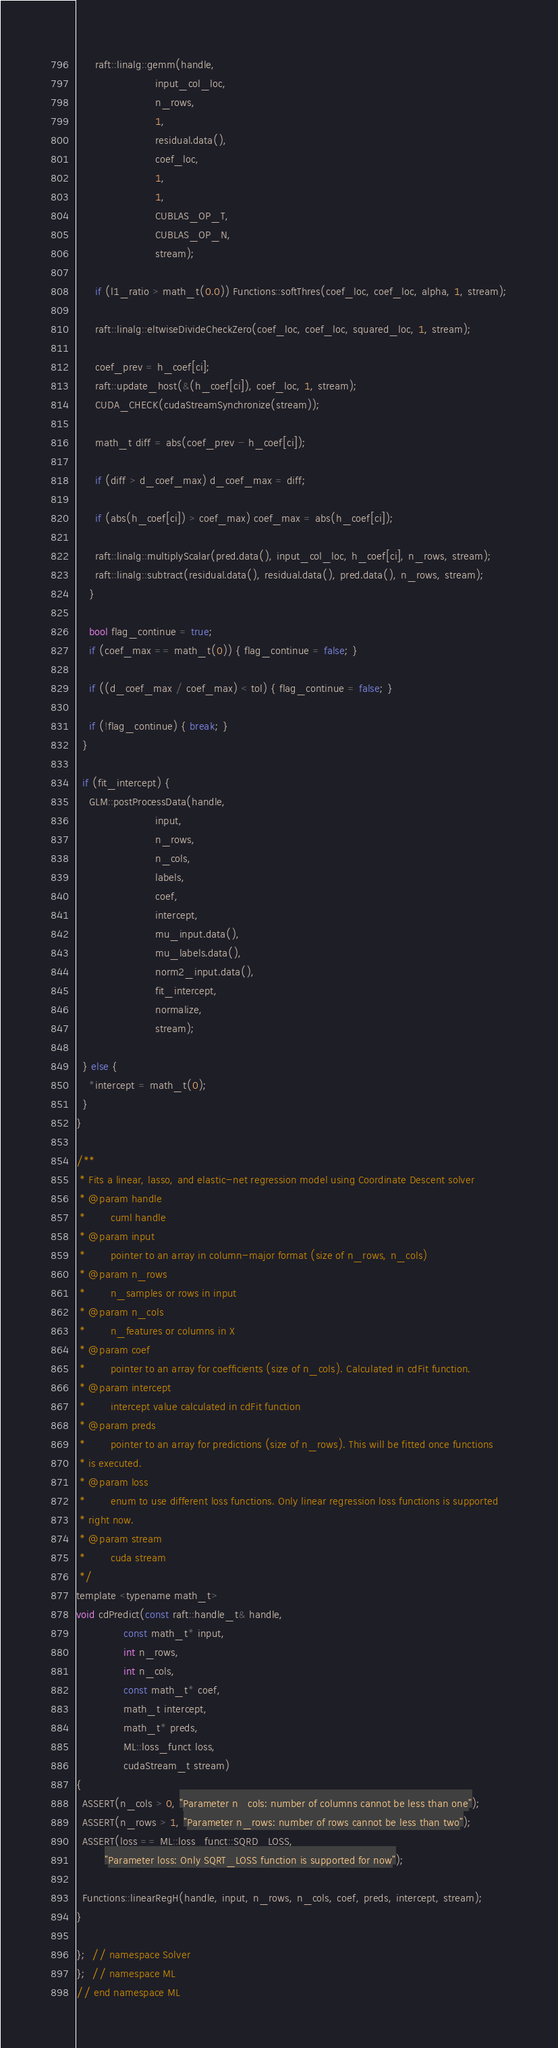Convert code to text. <code><loc_0><loc_0><loc_500><loc_500><_Cuda_>      raft::linalg::gemm(handle,
                         input_col_loc,
                         n_rows,
                         1,
                         residual.data(),
                         coef_loc,
                         1,
                         1,
                         CUBLAS_OP_T,
                         CUBLAS_OP_N,
                         stream);

      if (l1_ratio > math_t(0.0)) Functions::softThres(coef_loc, coef_loc, alpha, 1, stream);

      raft::linalg::eltwiseDivideCheckZero(coef_loc, coef_loc, squared_loc, 1, stream);

      coef_prev = h_coef[ci];
      raft::update_host(&(h_coef[ci]), coef_loc, 1, stream);
      CUDA_CHECK(cudaStreamSynchronize(stream));

      math_t diff = abs(coef_prev - h_coef[ci]);

      if (diff > d_coef_max) d_coef_max = diff;

      if (abs(h_coef[ci]) > coef_max) coef_max = abs(h_coef[ci]);

      raft::linalg::multiplyScalar(pred.data(), input_col_loc, h_coef[ci], n_rows, stream);
      raft::linalg::subtract(residual.data(), residual.data(), pred.data(), n_rows, stream);
    }

    bool flag_continue = true;
    if (coef_max == math_t(0)) { flag_continue = false; }

    if ((d_coef_max / coef_max) < tol) { flag_continue = false; }

    if (!flag_continue) { break; }
  }

  if (fit_intercept) {
    GLM::postProcessData(handle,
                         input,
                         n_rows,
                         n_cols,
                         labels,
                         coef,
                         intercept,
                         mu_input.data(),
                         mu_labels.data(),
                         norm2_input.data(),
                         fit_intercept,
                         normalize,
                         stream);

  } else {
    *intercept = math_t(0);
  }
}

/**
 * Fits a linear, lasso, and elastic-net regression model using Coordinate Descent solver
 * @param handle
 *        cuml handle
 * @param input
 *        pointer to an array in column-major format (size of n_rows, n_cols)
 * @param n_rows
 *        n_samples or rows in input
 * @param n_cols
 *        n_features or columns in X
 * @param coef
 *        pointer to an array for coefficients (size of n_cols). Calculated in cdFit function.
 * @param intercept
 *        intercept value calculated in cdFit function
 * @param preds
 *        pointer to an array for predictions (size of n_rows). This will be fitted once functions
 * is executed.
 * @param loss
 *        enum to use different loss functions. Only linear regression loss functions is supported
 * right now.
 * @param stream
 *        cuda stream
 */
template <typename math_t>
void cdPredict(const raft::handle_t& handle,
               const math_t* input,
               int n_rows,
               int n_cols,
               const math_t* coef,
               math_t intercept,
               math_t* preds,
               ML::loss_funct loss,
               cudaStream_t stream)
{
  ASSERT(n_cols > 0, "Parameter n_cols: number of columns cannot be less than one");
  ASSERT(n_rows > 1, "Parameter n_rows: number of rows cannot be less than two");
  ASSERT(loss == ML::loss_funct::SQRD_LOSS,
         "Parameter loss: Only SQRT_LOSS function is supported for now");

  Functions::linearRegH(handle, input, n_rows, n_cols, coef, preds, intercept, stream);
}

};  // namespace Solver
};  // namespace ML
// end namespace ML
</code> 